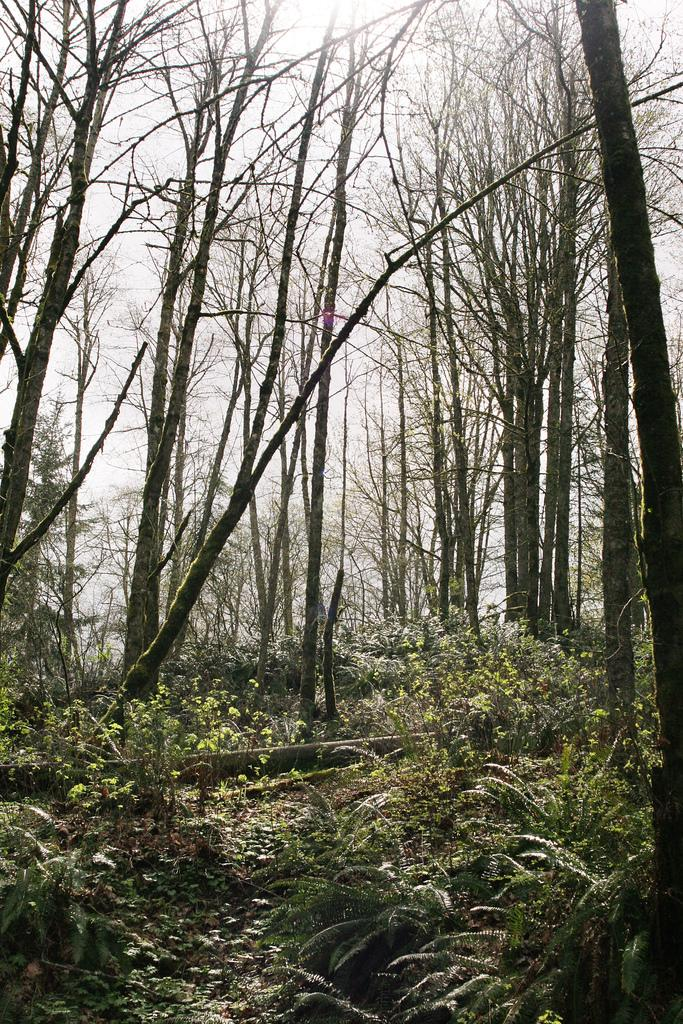What type of vegetation is present on the ground in the image? There are plants on the ground in the image. What can be seen in the background of the image? The sky is visible in the background of the image. What type of reaction does the volleyball have when it hits the ground in the image? There is no volleyball present in the image, so it is not possible to answer that question. 